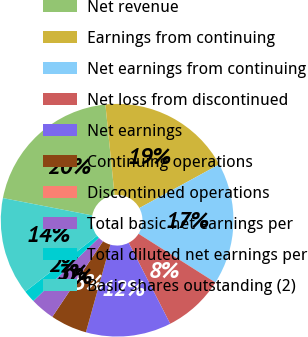<chart> <loc_0><loc_0><loc_500><loc_500><pie_chart><fcel>Net revenue<fcel>Earnings from continuing<fcel>Net earnings from continuing<fcel>Net loss from discontinued<fcel>Net earnings<fcel>Continuing operations<fcel>Discontinued operations<fcel>Total basic net earnings per<fcel>Total diluted net earnings per<fcel>Basic shares outstanding (2)<nl><fcel>20.34%<fcel>18.64%<fcel>16.95%<fcel>8.47%<fcel>11.86%<fcel>5.08%<fcel>0.0%<fcel>3.39%<fcel>1.69%<fcel>13.56%<nl></chart> 